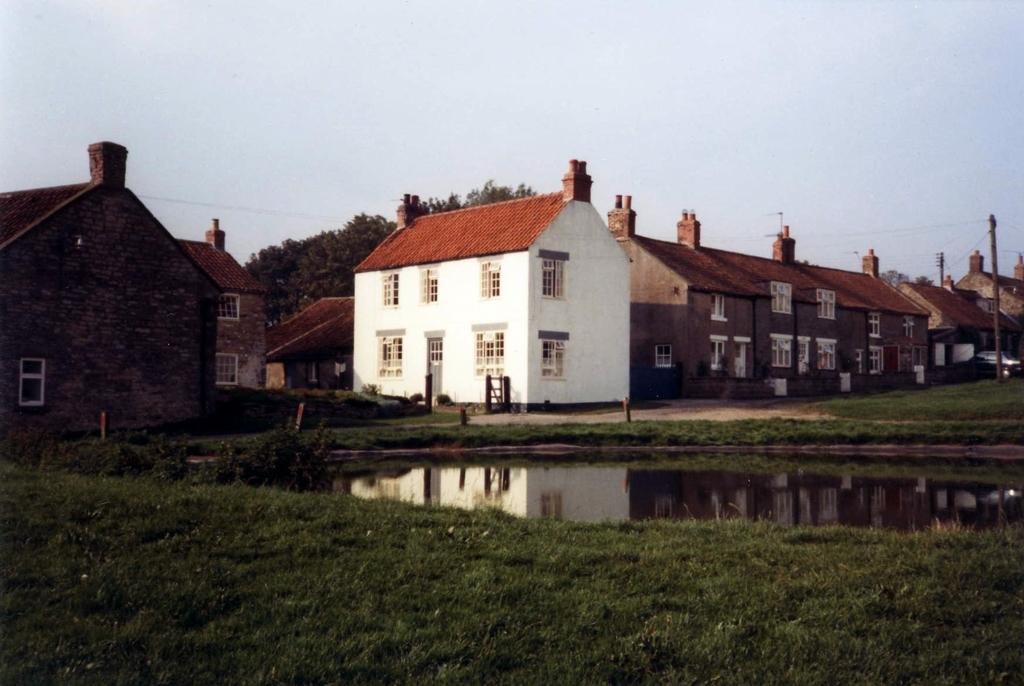What type of vegetation is visible in the foreground of the image? There is grass in front of the image. What natural feature is located behind the grass? There is a lake behind the grass. What structures can be seen in the background of the image? There are houses and trees in the background of the image. What man-made objects are present in the background of the image? There are poles with electrical cables in the background of the image. How much salt is present in the lake in the image? There is no information about the salt content of the lake in the image. What unit of measurement is used to determine the height of the trees in the image? There is no information about measuring the height of the trees in the image. 